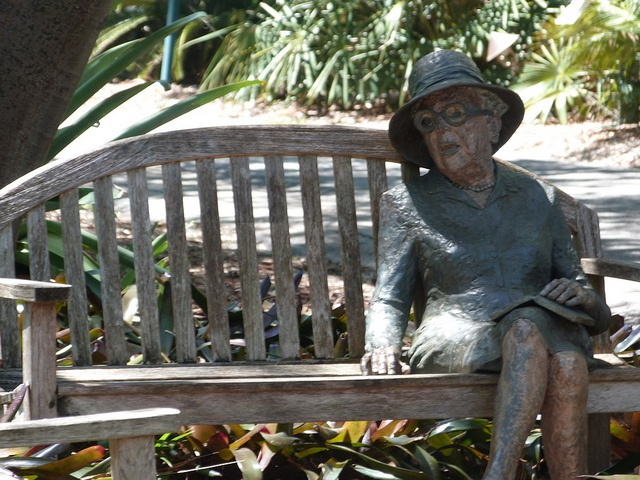Describe the objects in this image and their specific colors. I can see bench in black, gray, white, and darkgray tones and people in black, gray, purple, and white tones in this image. 